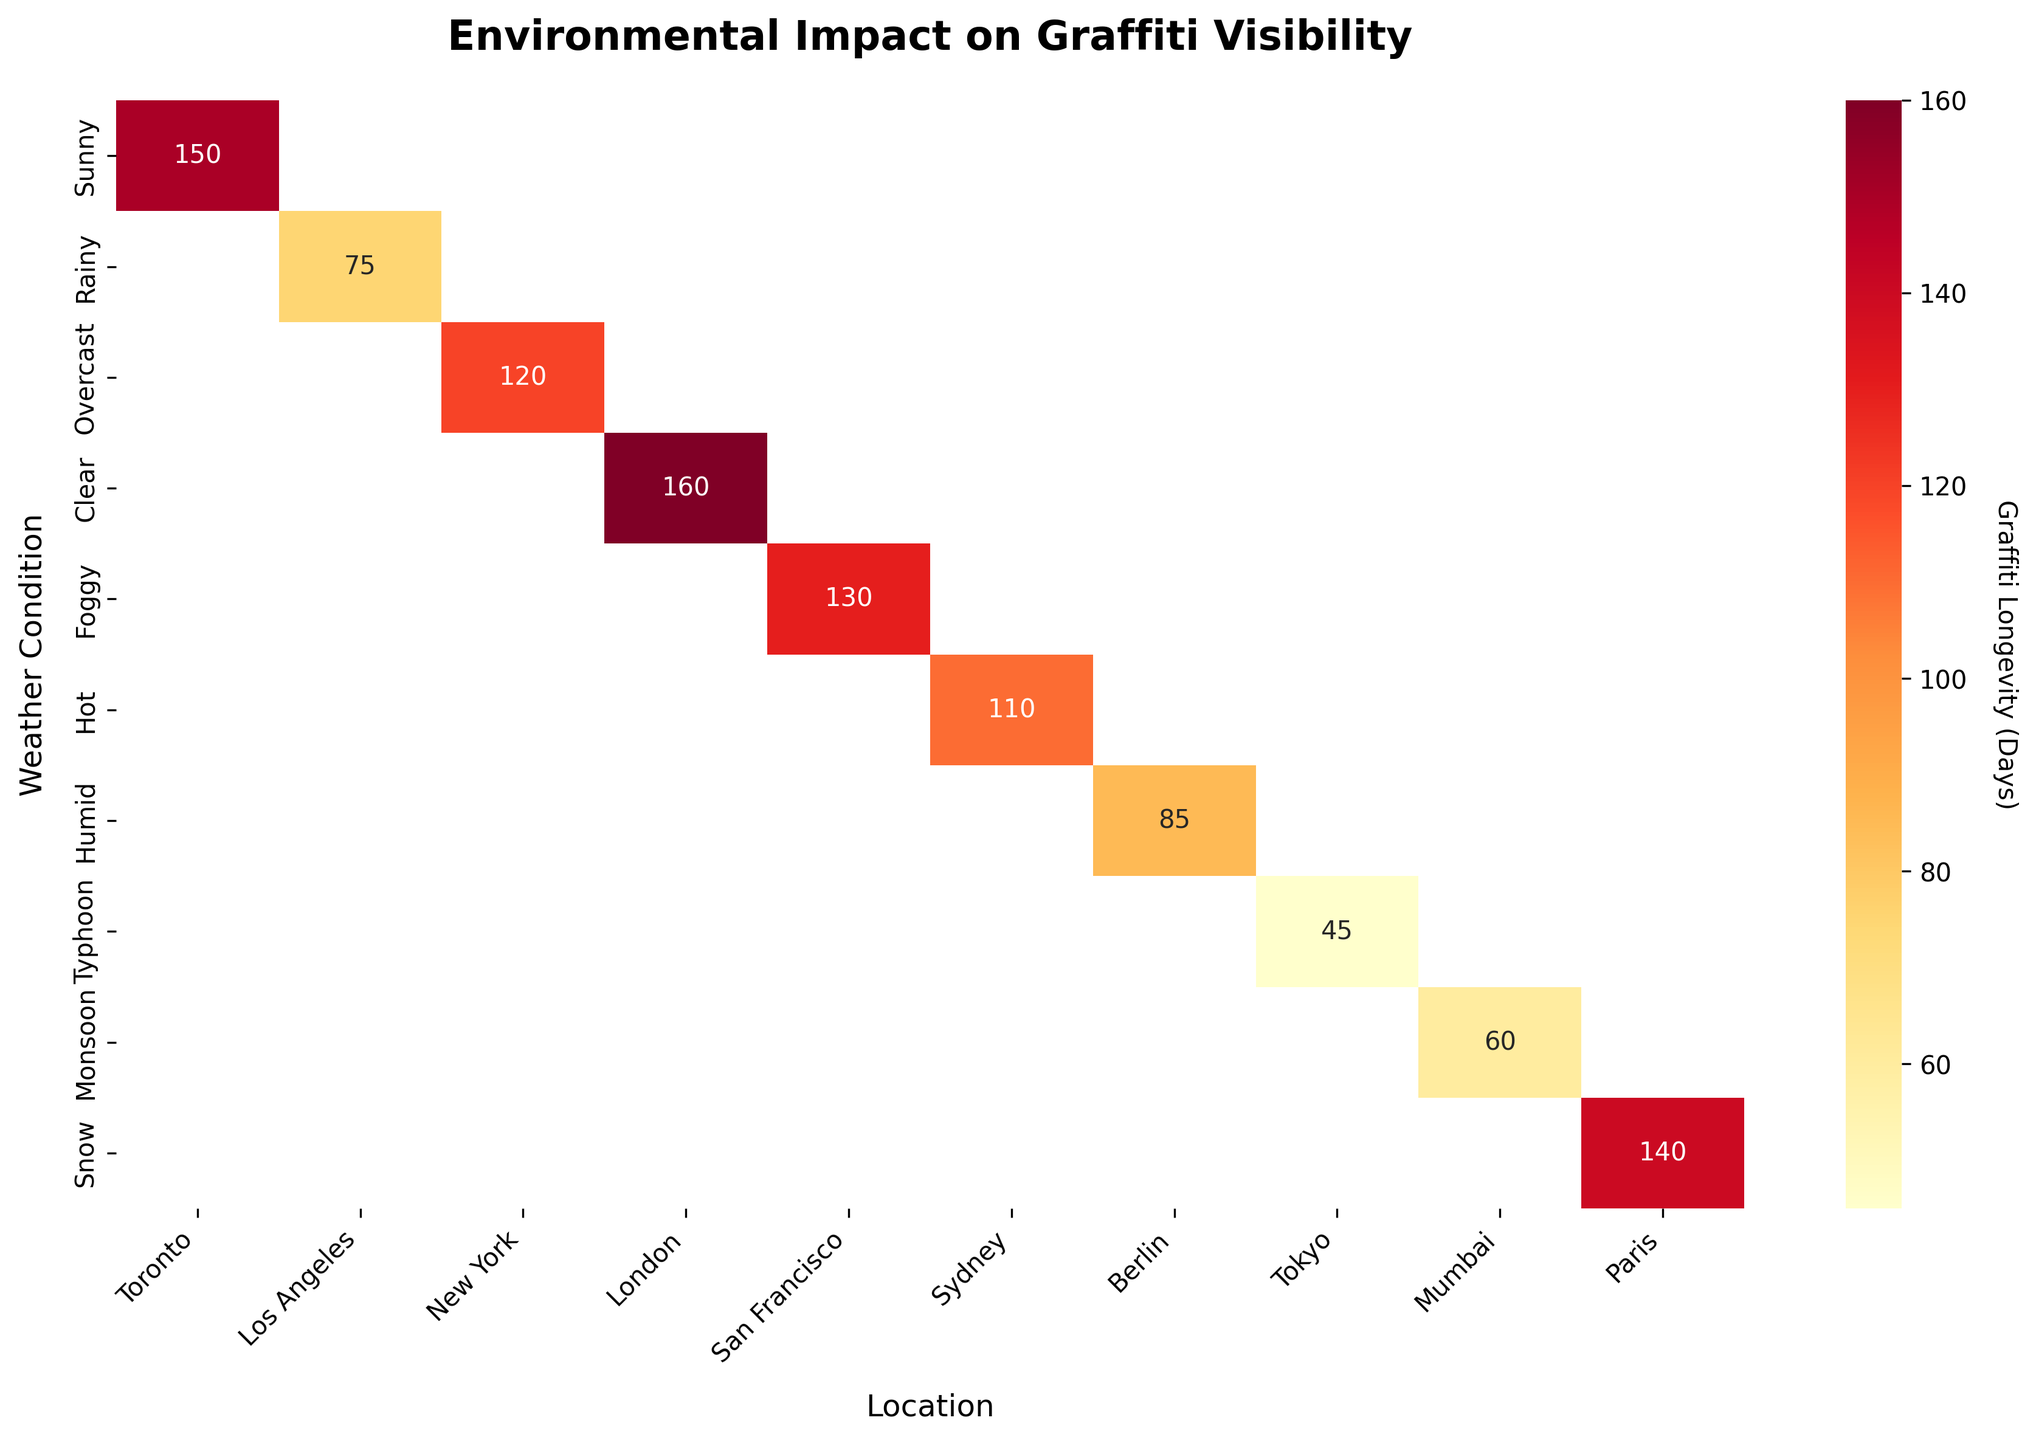What's the title of the heatmap? The title of the heatmap is written at the top, usually in a larger and bold font size to differentiate it from other text.
Answer: Environmental Impact on Graffiti Visibility What weather condition is linked with the shortest graffiti longevity? Check the heatmap data and look for the cell with the smallest number, which corresponds to the shortest longevity. Identify the corresponding weather condition from the left y-axis.
Answer: Typhoon Which location has the highest graffiti longevity in clear weather? Locate the row labeled 'Clear' on the y-axis, then find the cell with the highest value, and its corresponding location on the x-axis.
Answer: London How does graffiti longevity in Tokyo under Typhoon conditions compare to Mumbai during Monsoon? Find the cells for 'Typhoon' in Tokyo and 'Monsoon' in Mumbai. Compare their numerical values to determine which is higher.
Answer: Typhoon (45 days) is shorter than Monsoon (60 days) Which location tends to maintain visibility of graffiti longer across different weather conditions? Examine the heatmap for each location column and identify which one has generally higher values compared to others. This can be determined by observing the consistency of higher numbers in a particular column.
Answer: London On average, how long does graffiti last in foggy conditions? Locate the row labeled 'Foggy' and find all values in that row. Sum these values and divide by the number of data points present to get the average.
Answer: 130 days What is the difference in graffiti longevity between Paris in Snow and Sydney in Hot conditions? Identify the value for Paris under 'Snow' and Sydney under 'Hot'. Subtract the value of Sydney from the value of Paris to find the difference.
Answer: 140 - 110 = 30 days For which weather condition did London have the graffiti lasting the longest? Look for the 'London' column and identify the highest value. Then, check the corresponding weather condition on the y-axis for this highest value.
Answer: Clear If you were to rank the weather conditions by average graffiti longevity, which one would come first? Calculate the average longevity for each weather condition by summing the values in each row and dividing by the count of non-NaN values. The condition with the highest average comes first.
Answer: Clear How many days does graffiti last in Berlin under humid conditions? Locate the cell corresponding to 'Berlin' under 'Humid' and read the value directly from that cell.
Answer: 85 days 